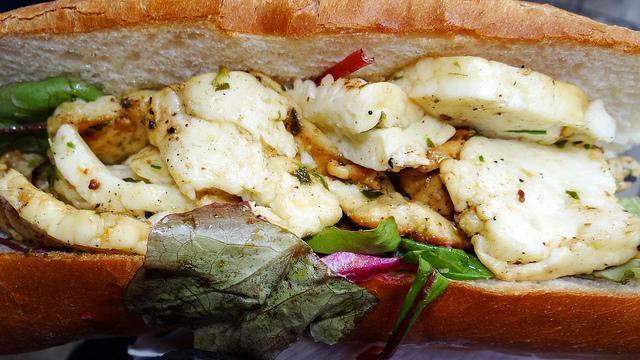How many sandwiches are there?
Give a very brief answer. 1. 